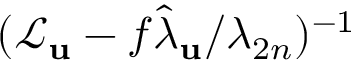<formula> <loc_0><loc_0><loc_500><loc_500>( \mathcal { L } _ { u } - f \hat { \lambda } _ { u } / \lambda _ { 2 n } ) ^ { - 1 }</formula> 